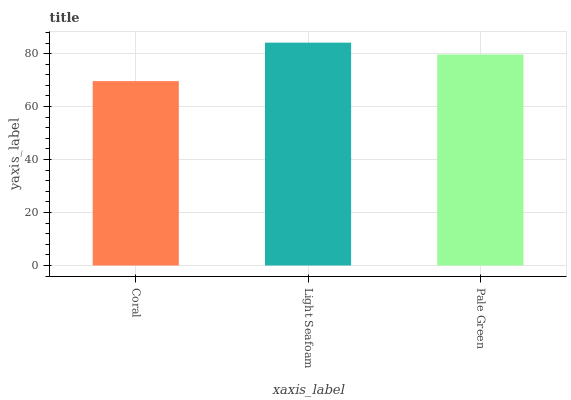Is Pale Green the minimum?
Answer yes or no. No. Is Pale Green the maximum?
Answer yes or no. No. Is Light Seafoam greater than Pale Green?
Answer yes or no. Yes. Is Pale Green less than Light Seafoam?
Answer yes or no. Yes. Is Pale Green greater than Light Seafoam?
Answer yes or no. No. Is Light Seafoam less than Pale Green?
Answer yes or no. No. Is Pale Green the high median?
Answer yes or no. Yes. Is Pale Green the low median?
Answer yes or no. Yes. Is Coral the high median?
Answer yes or no. No. Is Coral the low median?
Answer yes or no. No. 